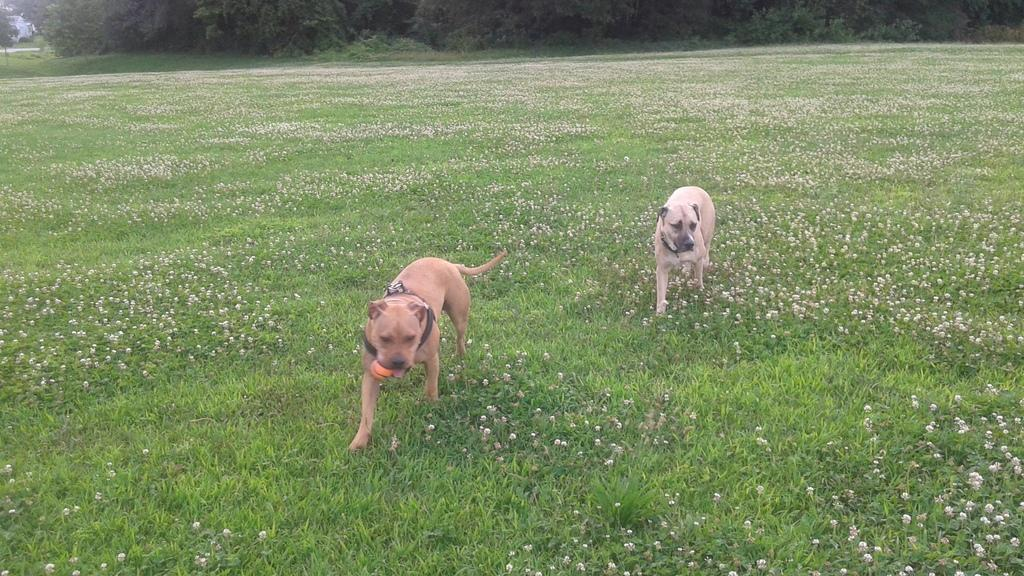What type of living organisms can be seen in the grass in the image? There are plants in the grass in the image. What animals are in the middle of the image? There are two dogs in the middle of the image. What type of vegetation is visible at the top of the image? There are trees at the top of the image. What type of engine can be seen powering the arch in the image? There is no engine or arch present in the image. What is the tax rate for the plants in the image? There is no mention of taxes in the image, and plants do not pay taxes. 